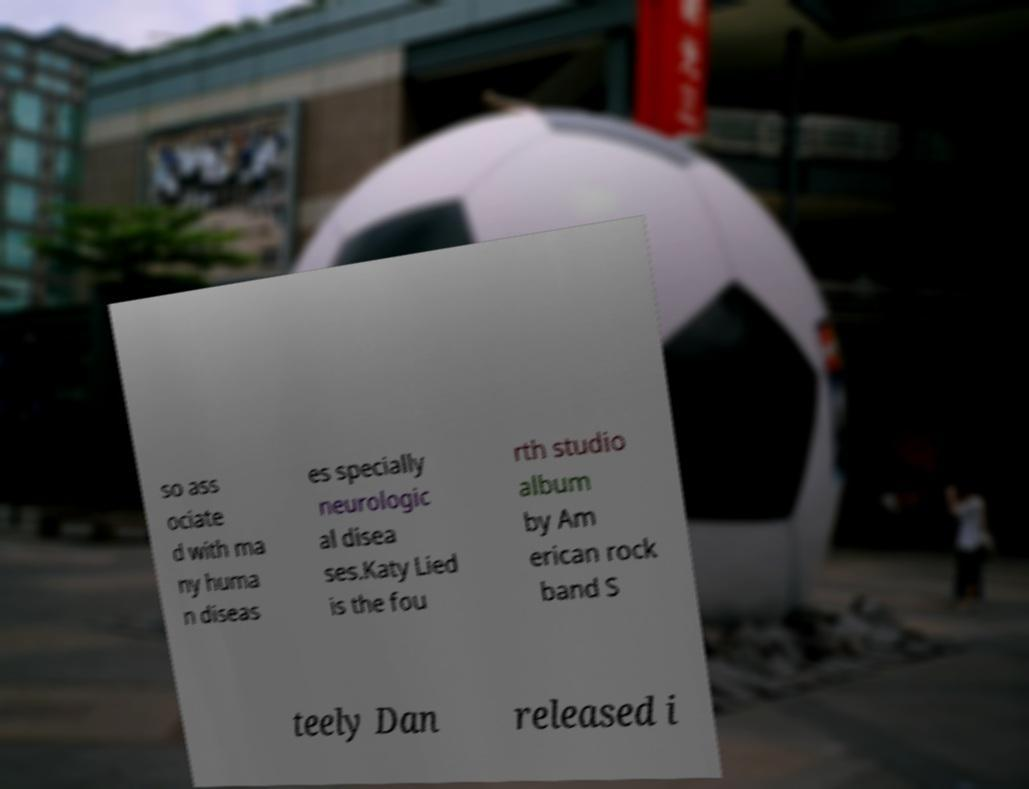There's text embedded in this image that I need extracted. Can you transcribe it verbatim? so ass ociate d with ma ny huma n diseas es specially neurologic al disea ses.Katy Lied is the fou rth studio album by Am erican rock band S teely Dan released i 